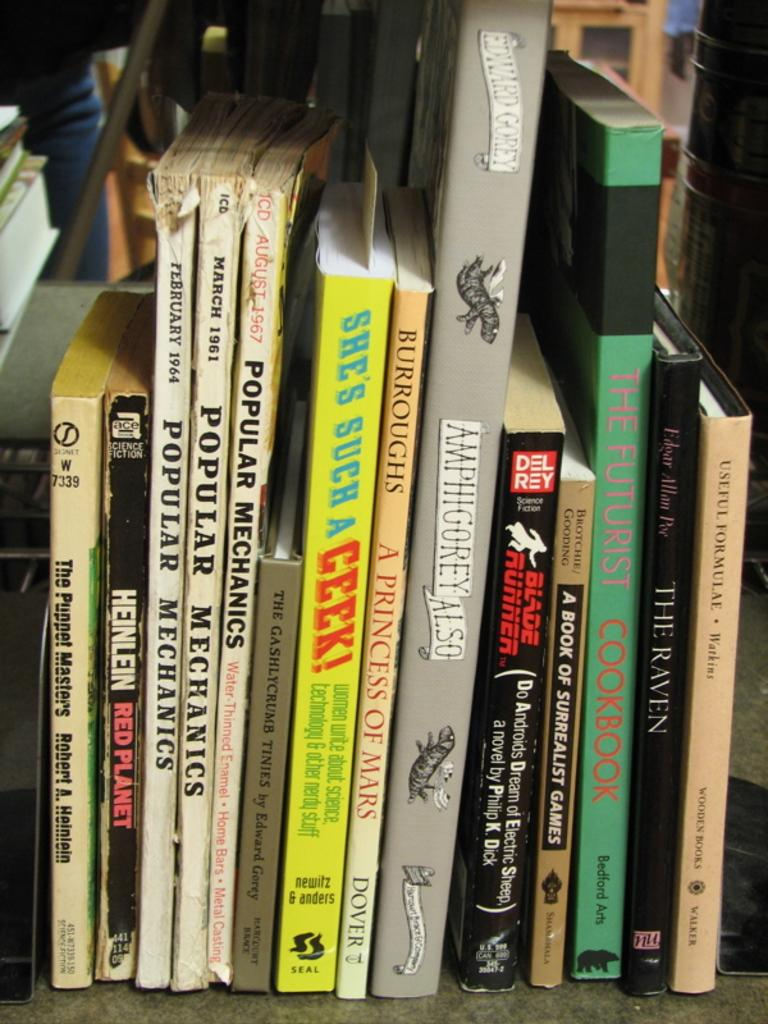<image>
Summarize the visual content of the image. Several books sit on a shelf, in particular there are 3 Popular mechanics books. 